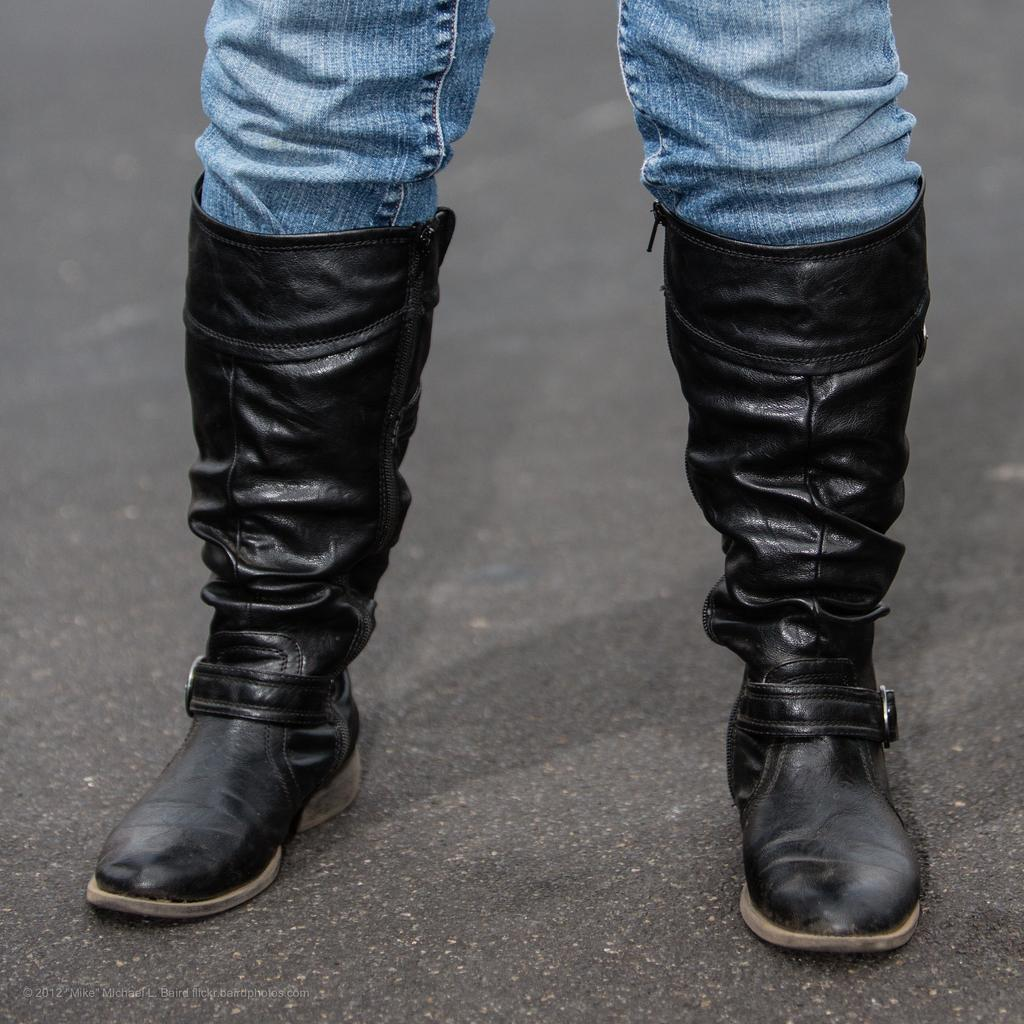What part of a person can be seen in the image? There are legs of a person visible in the image. Where are the legs located? The legs are on the road. What type of business is being conducted by the person with the guitar in the image? There is no person with a guitar present in the image. 